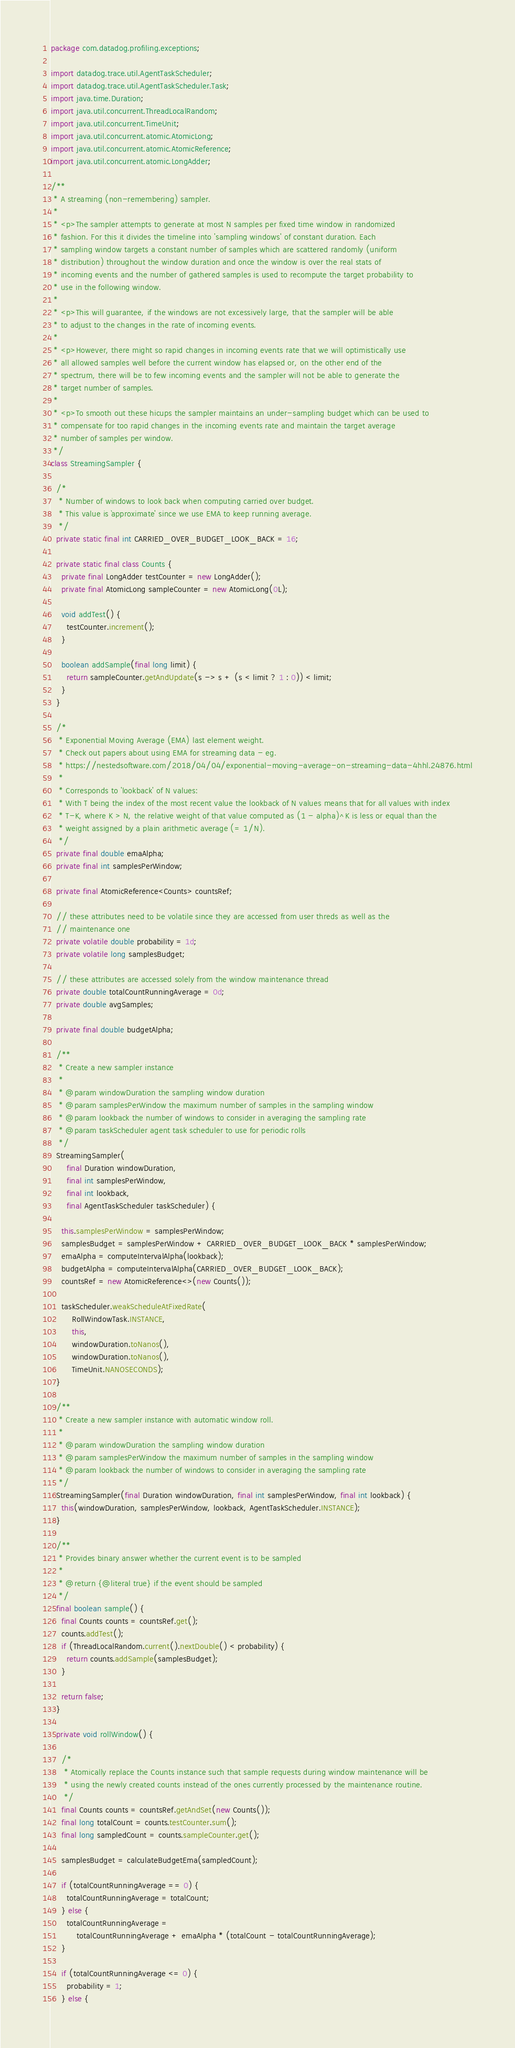<code> <loc_0><loc_0><loc_500><loc_500><_Java_>package com.datadog.profiling.exceptions;

import datadog.trace.util.AgentTaskScheduler;
import datadog.trace.util.AgentTaskScheduler.Task;
import java.time.Duration;
import java.util.concurrent.ThreadLocalRandom;
import java.util.concurrent.TimeUnit;
import java.util.concurrent.atomic.AtomicLong;
import java.util.concurrent.atomic.AtomicReference;
import java.util.concurrent.atomic.LongAdder;

/**
 * A streaming (non-remembering) sampler.
 *
 * <p>The sampler attempts to generate at most N samples per fixed time window in randomized
 * fashion. For this it divides the timeline into 'sampling windows' of constant duration. Each
 * sampling window targets a constant number of samples which are scattered randomly (uniform
 * distribution) throughout the window duration and once the window is over the real stats of
 * incoming events and the number of gathered samples is used to recompute the target probability to
 * use in the following window.
 *
 * <p>This will guarantee, if the windows are not excessively large, that the sampler will be able
 * to adjust to the changes in the rate of incoming events.
 *
 * <p>However, there might so rapid changes in incoming events rate that we will optimistically use
 * all allowed samples well before the current window has elapsed or, on the other end of the
 * spectrum, there will be to few incoming events and the sampler will not be able to generate the
 * target number of samples.
 *
 * <p>To smooth out these hicups the sampler maintains an under-sampling budget which can be used to
 * compensate for too rapid changes in the incoming events rate and maintain the target average
 * number of samples per window.
 */
class StreamingSampler {

  /*
   * Number of windows to look back when computing carried over budget.
   * This value is `approximate' since we use EMA to keep running average.
   */
  private static final int CARRIED_OVER_BUDGET_LOOK_BACK = 16;

  private static final class Counts {
    private final LongAdder testCounter = new LongAdder();
    private final AtomicLong sampleCounter = new AtomicLong(0L);

    void addTest() {
      testCounter.increment();
    }

    boolean addSample(final long limit) {
      return sampleCounter.getAndUpdate(s -> s + (s < limit ? 1 : 0)) < limit;
    }
  }

  /*
   * Exponential Moving Average (EMA) last element weight.
   * Check out papers about using EMA for streaming data - eg.
   * https://nestedsoftware.com/2018/04/04/exponential-moving-average-on-streaming-data-4hhl.24876.html
   *
   * Corresponds to 'lookback' of N values:
   * With T being the index of the most recent value the lookback of N values means that for all values with index
   * T-K, where K > N, the relative weight of that value computed as (1 - alpha)^K is less or equal than the
   * weight assigned by a plain arithmetic average (= 1/N).
   */
  private final double emaAlpha;
  private final int samplesPerWindow;

  private final AtomicReference<Counts> countsRef;

  // these attributes need to be volatile since they are accessed from user threds as well as the
  // maintenance one
  private volatile double probability = 1d;
  private volatile long samplesBudget;

  // these attributes are accessed solely from the window maintenance thread
  private double totalCountRunningAverage = 0d;
  private double avgSamples;

  private final double budgetAlpha;

  /**
   * Create a new sampler instance
   *
   * @param windowDuration the sampling window duration
   * @param samplesPerWindow the maximum number of samples in the sampling window
   * @param lookback the number of windows to consider in averaging the sampling rate
   * @param taskScheduler agent task scheduler to use for periodic rolls
   */
  StreamingSampler(
      final Duration windowDuration,
      final int samplesPerWindow,
      final int lookback,
      final AgentTaskScheduler taskScheduler) {

    this.samplesPerWindow = samplesPerWindow;
    samplesBudget = samplesPerWindow + CARRIED_OVER_BUDGET_LOOK_BACK * samplesPerWindow;
    emaAlpha = computeIntervalAlpha(lookback);
    budgetAlpha = computeIntervalAlpha(CARRIED_OVER_BUDGET_LOOK_BACK);
    countsRef = new AtomicReference<>(new Counts());

    taskScheduler.weakScheduleAtFixedRate(
        RollWindowTask.INSTANCE,
        this,
        windowDuration.toNanos(),
        windowDuration.toNanos(),
        TimeUnit.NANOSECONDS);
  }

  /**
   * Create a new sampler instance with automatic window roll.
   *
   * @param windowDuration the sampling window duration
   * @param samplesPerWindow the maximum number of samples in the sampling window
   * @param lookback the number of windows to consider in averaging the sampling rate
   */
  StreamingSampler(final Duration windowDuration, final int samplesPerWindow, final int lookback) {
    this(windowDuration, samplesPerWindow, lookback, AgentTaskScheduler.INSTANCE);
  }

  /**
   * Provides binary answer whether the current event is to be sampled
   *
   * @return {@literal true} if the event should be sampled
   */
  final boolean sample() {
    final Counts counts = countsRef.get();
    counts.addTest();
    if (ThreadLocalRandom.current().nextDouble() < probability) {
      return counts.addSample(samplesBudget);
    }

    return false;
  }

  private void rollWindow() {

    /*
     * Atomically replace the Counts instance such that sample requests during window maintenance will be
     * using the newly created counts instead of the ones currently processed by the maintenance routine.
     */
    final Counts counts = countsRef.getAndSet(new Counts());
    final long totalCount = counts.testCounter.sum();
    final long sampledCount = counts.sampleCounter.get();

    samplesBudget = calculateBudgetEma(sampledCount);

    if (totalCountRunningAverage == 0) {
      totalCountRunningAverage = totalCount;
    } else {
      totalCountRunningAverage =
          totalCountRunningAverage + emaAlpha * (totalCount - totalCountRunningAverage);
    }

    if (totalCountRunningAverage <= 0) {
      probability = 1;
    } else {</code> 